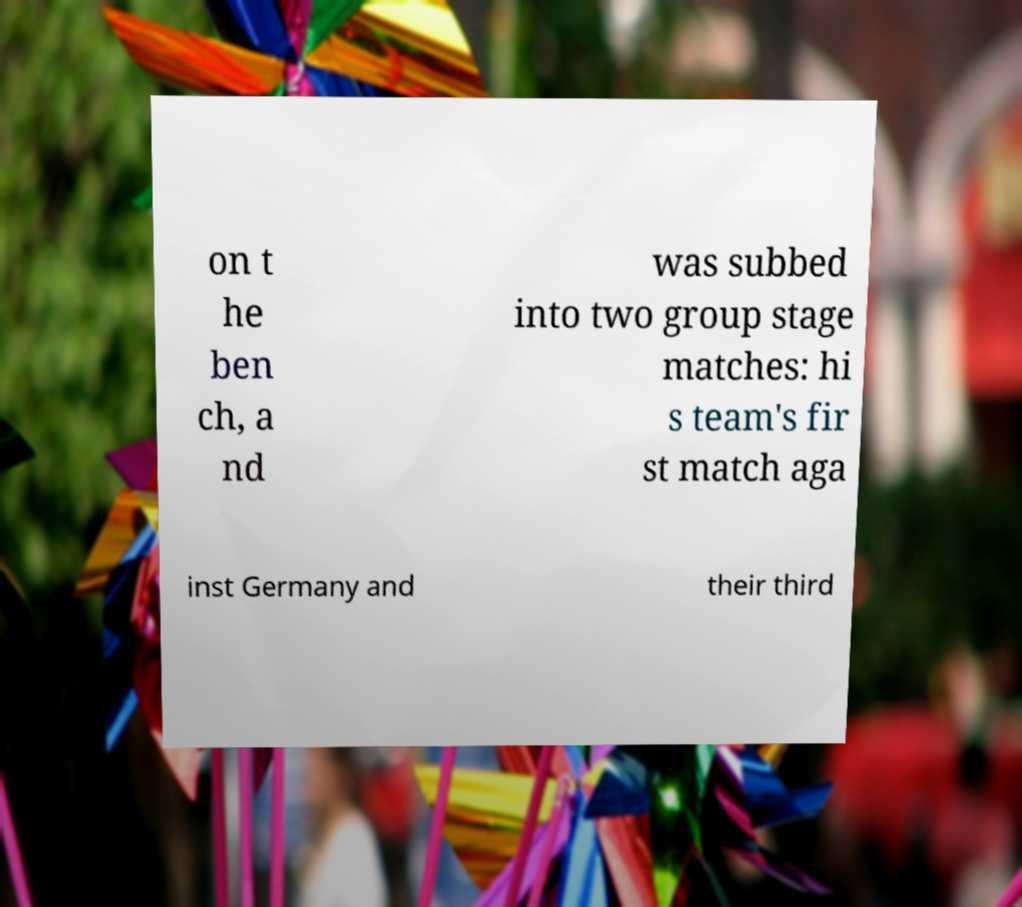Can you read and provide the text displayed in the image?This photo seems to have some interesting text. Can you extract and type it out for me? on t he ben ch, a nd was subbed into two group stage matches: hi s team's fir st match aga inst Germany and their third 